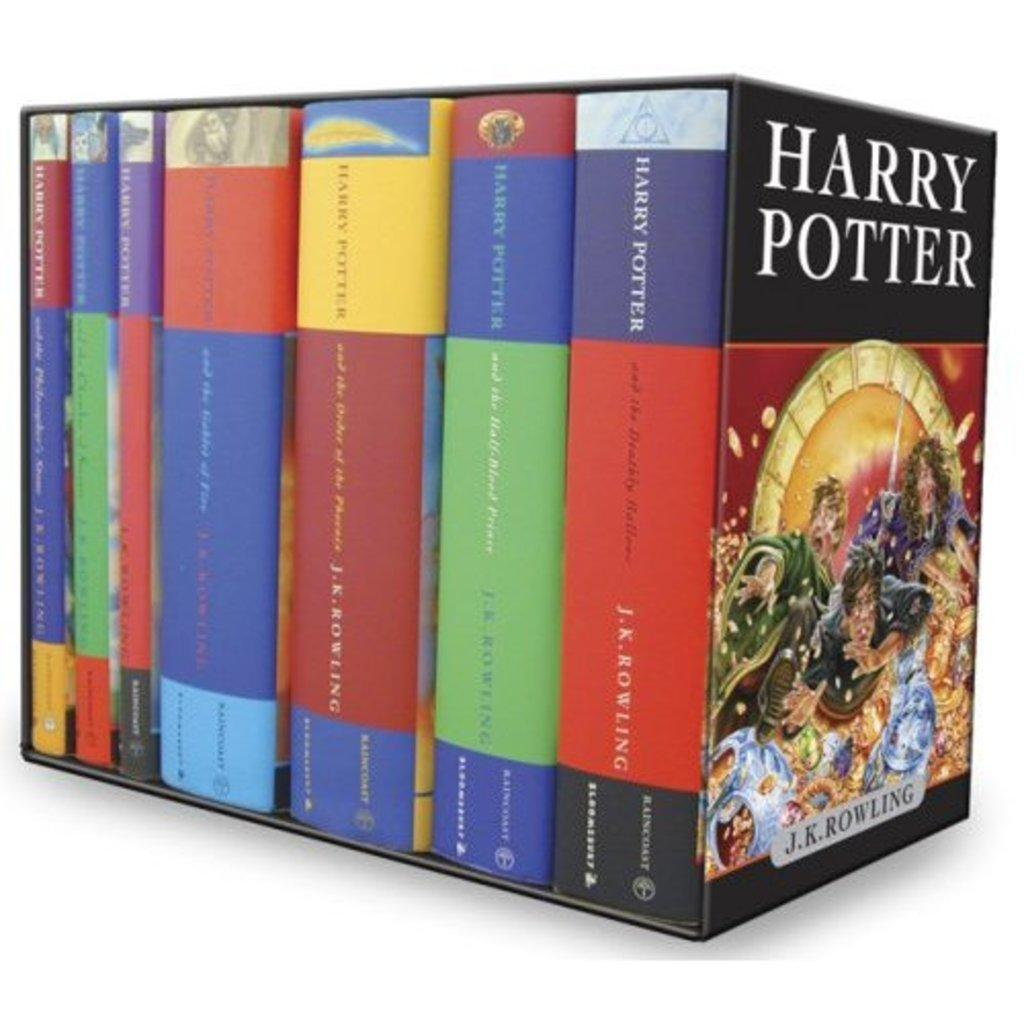<image>
Offer a succinct explanation of the picture presented. Collection of Harry Potter books by J.K. Rowling in a book case 